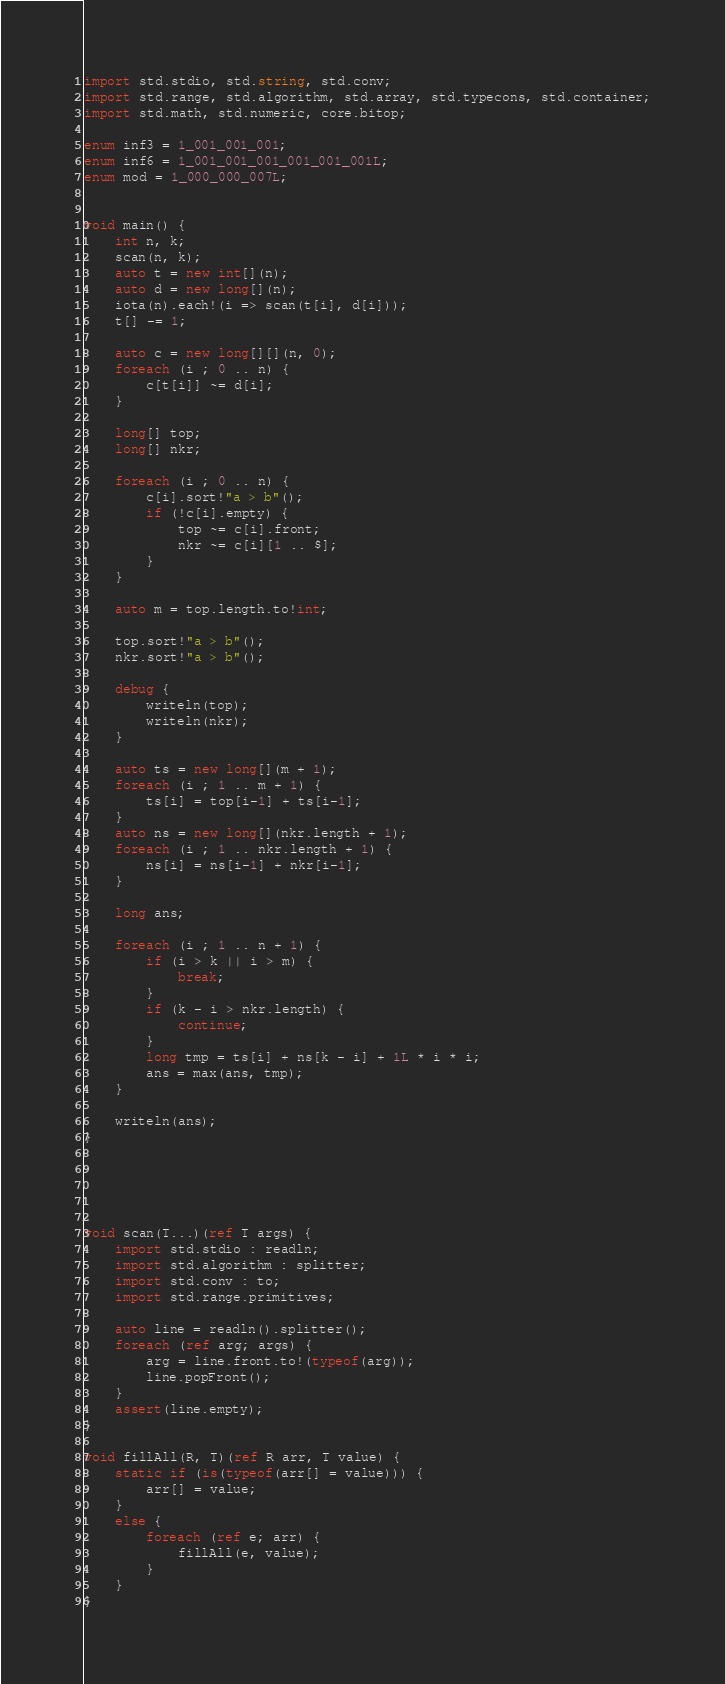Convert code to text. <code><loc_0><loc_0><loc_500><loc_500><_D_>import std.stdio, std.string, std.conv;
import std.range, std.algorithm, std.array, std.typecons, std.container;
import std.math, std.numeric, core.bitop;

enum inf3 = 1_001_001_001;
enum inf6 = 1_001_001_001_001_001_001L;
enum mod = 1_000_000_007L;


void main() {
    int n, k;
    scan(n, k);
    auto t = new int[](n);
    auto d = new long[](n);
    iota(n).each!(i => scan(t[i], d[i]));
    t[] -= 1;

    auto c = new long[][](n, 0);
    foreach (i ; 0 .. n) {
        c[t[i]] ~= d[i];
    }

    long[] top;
    long[] nkr;

    foreach (i ; 0 .. n) {
        c[i].sort!"a > b"();
        if (!c[i].empty) {
            top ~= c[i].front;
            nkr ~= c[i][1 .. $];
        }
    }

    auto m = top.length.to!int;

    top.sort!"a > b"();
    nkr.sort!"a > b"();

    debug {
        writeln(top);
        writeln(nkr);
    }

    auto ts = new long[](m + 1);
    foreach (i ; 1 .. m + 1) {
        ts[i] = top[i-1] + ts[i-1];
    }
    auto ns = new long[](nkr.length + 1);
    foreach (i ; 1 .. nkr.length + 1) {
        ns[i] = ns[i-1] + nkr[i-1];
    }

    long ans;

    foreach (i ; 1 .. n + 1) {
        if (i > k || i > m) {
            break;
        }
        if (k - i > nkr.length) {
            continue;
        }
        long tmp = ts[i] + ns[k - i] + 1L * i * i;
        ans = max(ans, tmp);
    }

    writeln(ans);
}





void scan(T...)(ref T args) {
    import std.stdio : readln;
    import std.algorithm : splitter;
    import std.conv : to;
    import std.range.primitives;

    auto line = readln().splitter();
    foreach (ref arg; args) {
        arg = line.front.to!(typeof(arg));
        line.popFront();
    }
    assert(line.empty);
}

void fillAll(R, T)(ref R arr, T value) {
    static if (is(typeof(arr[] = value))) {
        arr[] = value;
    }
    else {
        foreach (ref e; arr) {
            fillAll(e, value);
        }
    }
}
</code> 